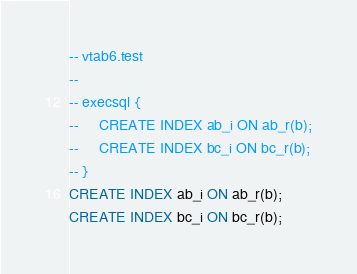Convert code to text. <code><loc_0><loc_0><loc_500><loc_500><_SQL_>-- vtab6.test
-- 
-- execsql {
--     CREATE INDEX ab_i ON ab_r(b);
--     CREATE INDEX bc_i ON bc_r(b);
-- }
CREATE INDEX ab_i ON ab_r(b);
CREATE INDEX bc_i ON bc_r(b);</code> 